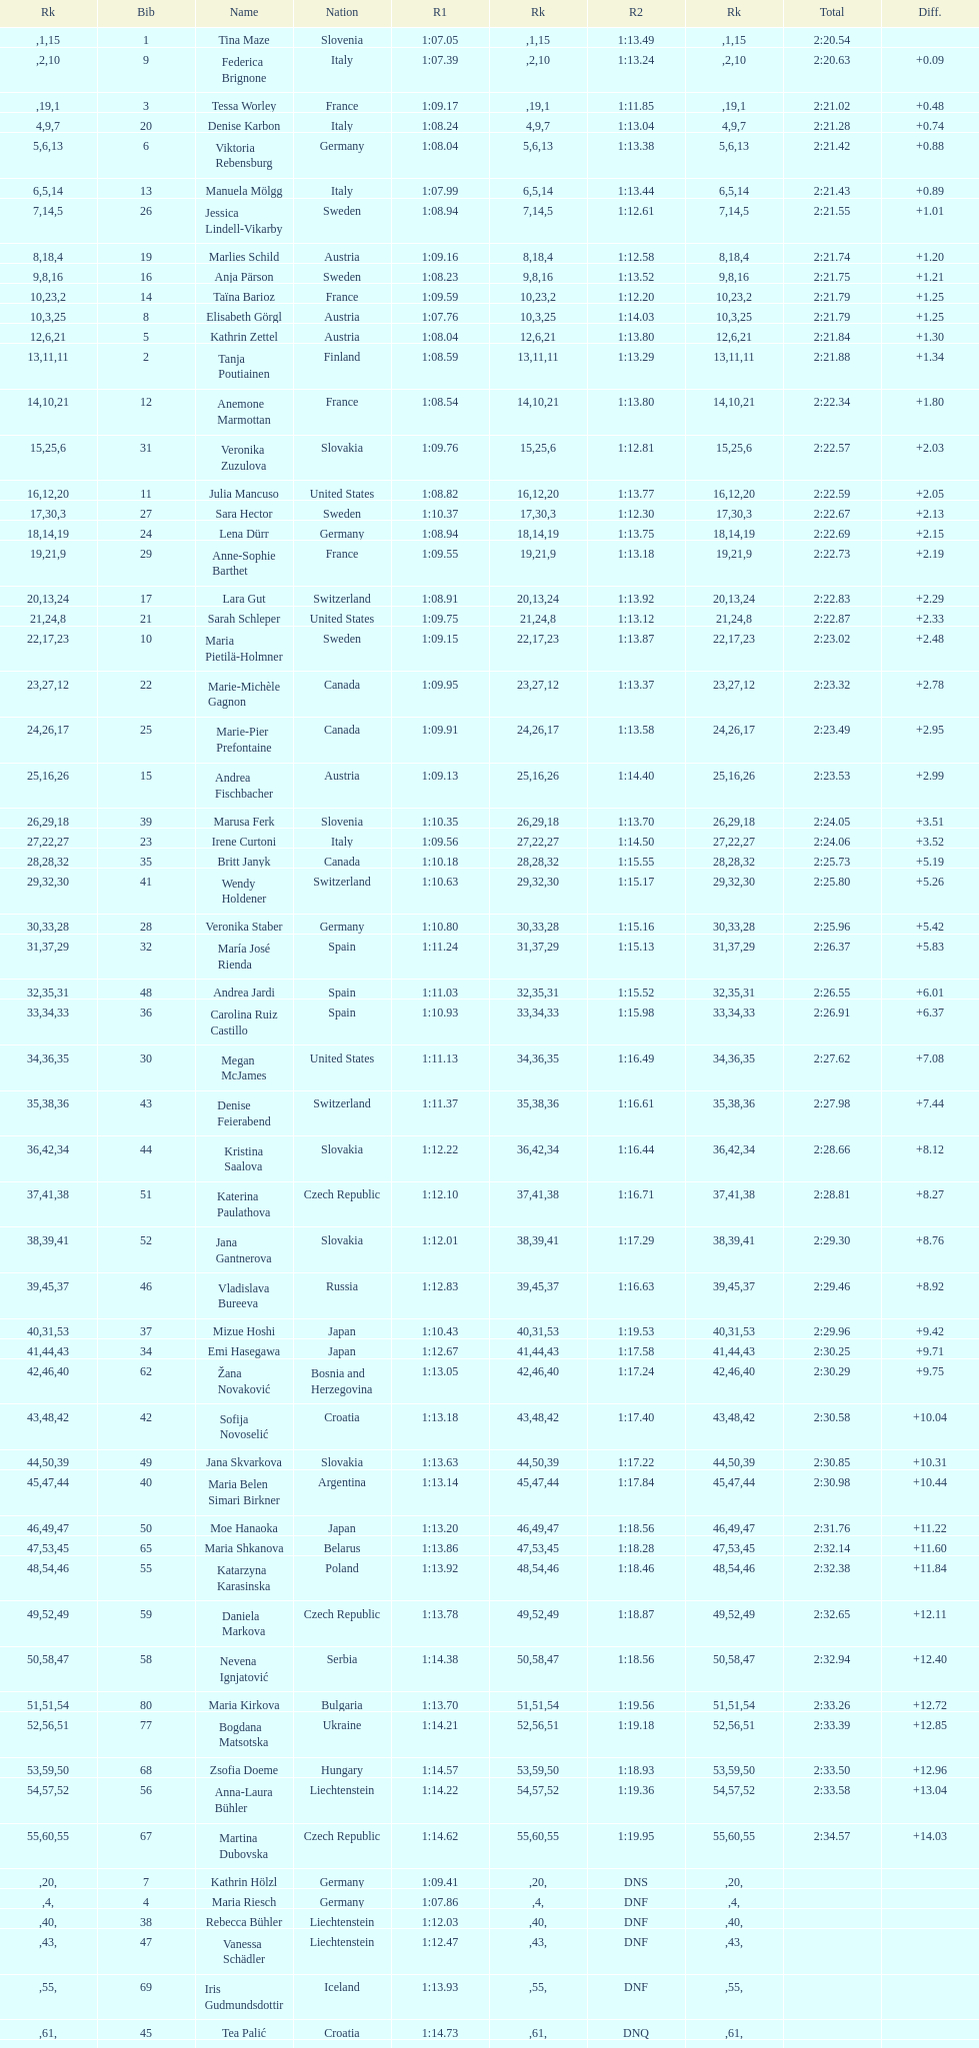In the top fifteen, what was the quantity of swedes? 2. 